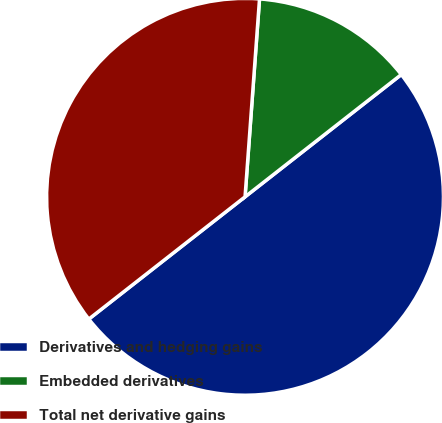<chart> <loc_0><loc_0><loc_500><loc_500><pie_chart><fcel>Derivatives and hedging gains<fcel>Embedded derivatives<fcel>Total net derivative gains<nl><fcel>50.0%<fcel>13.27%<fcel>36.73%<nl></chart> 